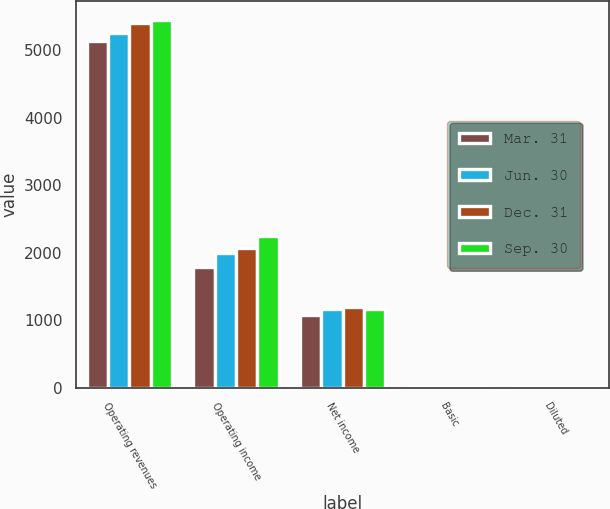<chart> <loc_0><loc_0><loc_500><loc_500><stacked_bar_chart><ecel><fcel>Operating revenues<fcel>Operating income<fcel>Net income<fcel>Basic<fcel>Diluted<nl><fcel>Mar. 31<fcel>5132<fcel>1788<fcel>1072<fcel>1.32<fcel>1.32<nl><fcel>Jun. 30<fcel>5250<fcel>1998<fcel>1168<fcel>1.45<fcel>1.45<nl><fcel>Dec. 31<fcel>5408<fcel>2073<fcel>1194<fcel>1.5<fcel>1.5<nl><fcel>Sep. 30<fcel>5450<fcel>2247<fcel>1168<fcel>9.29<fcel>9.25<nl></chart> 